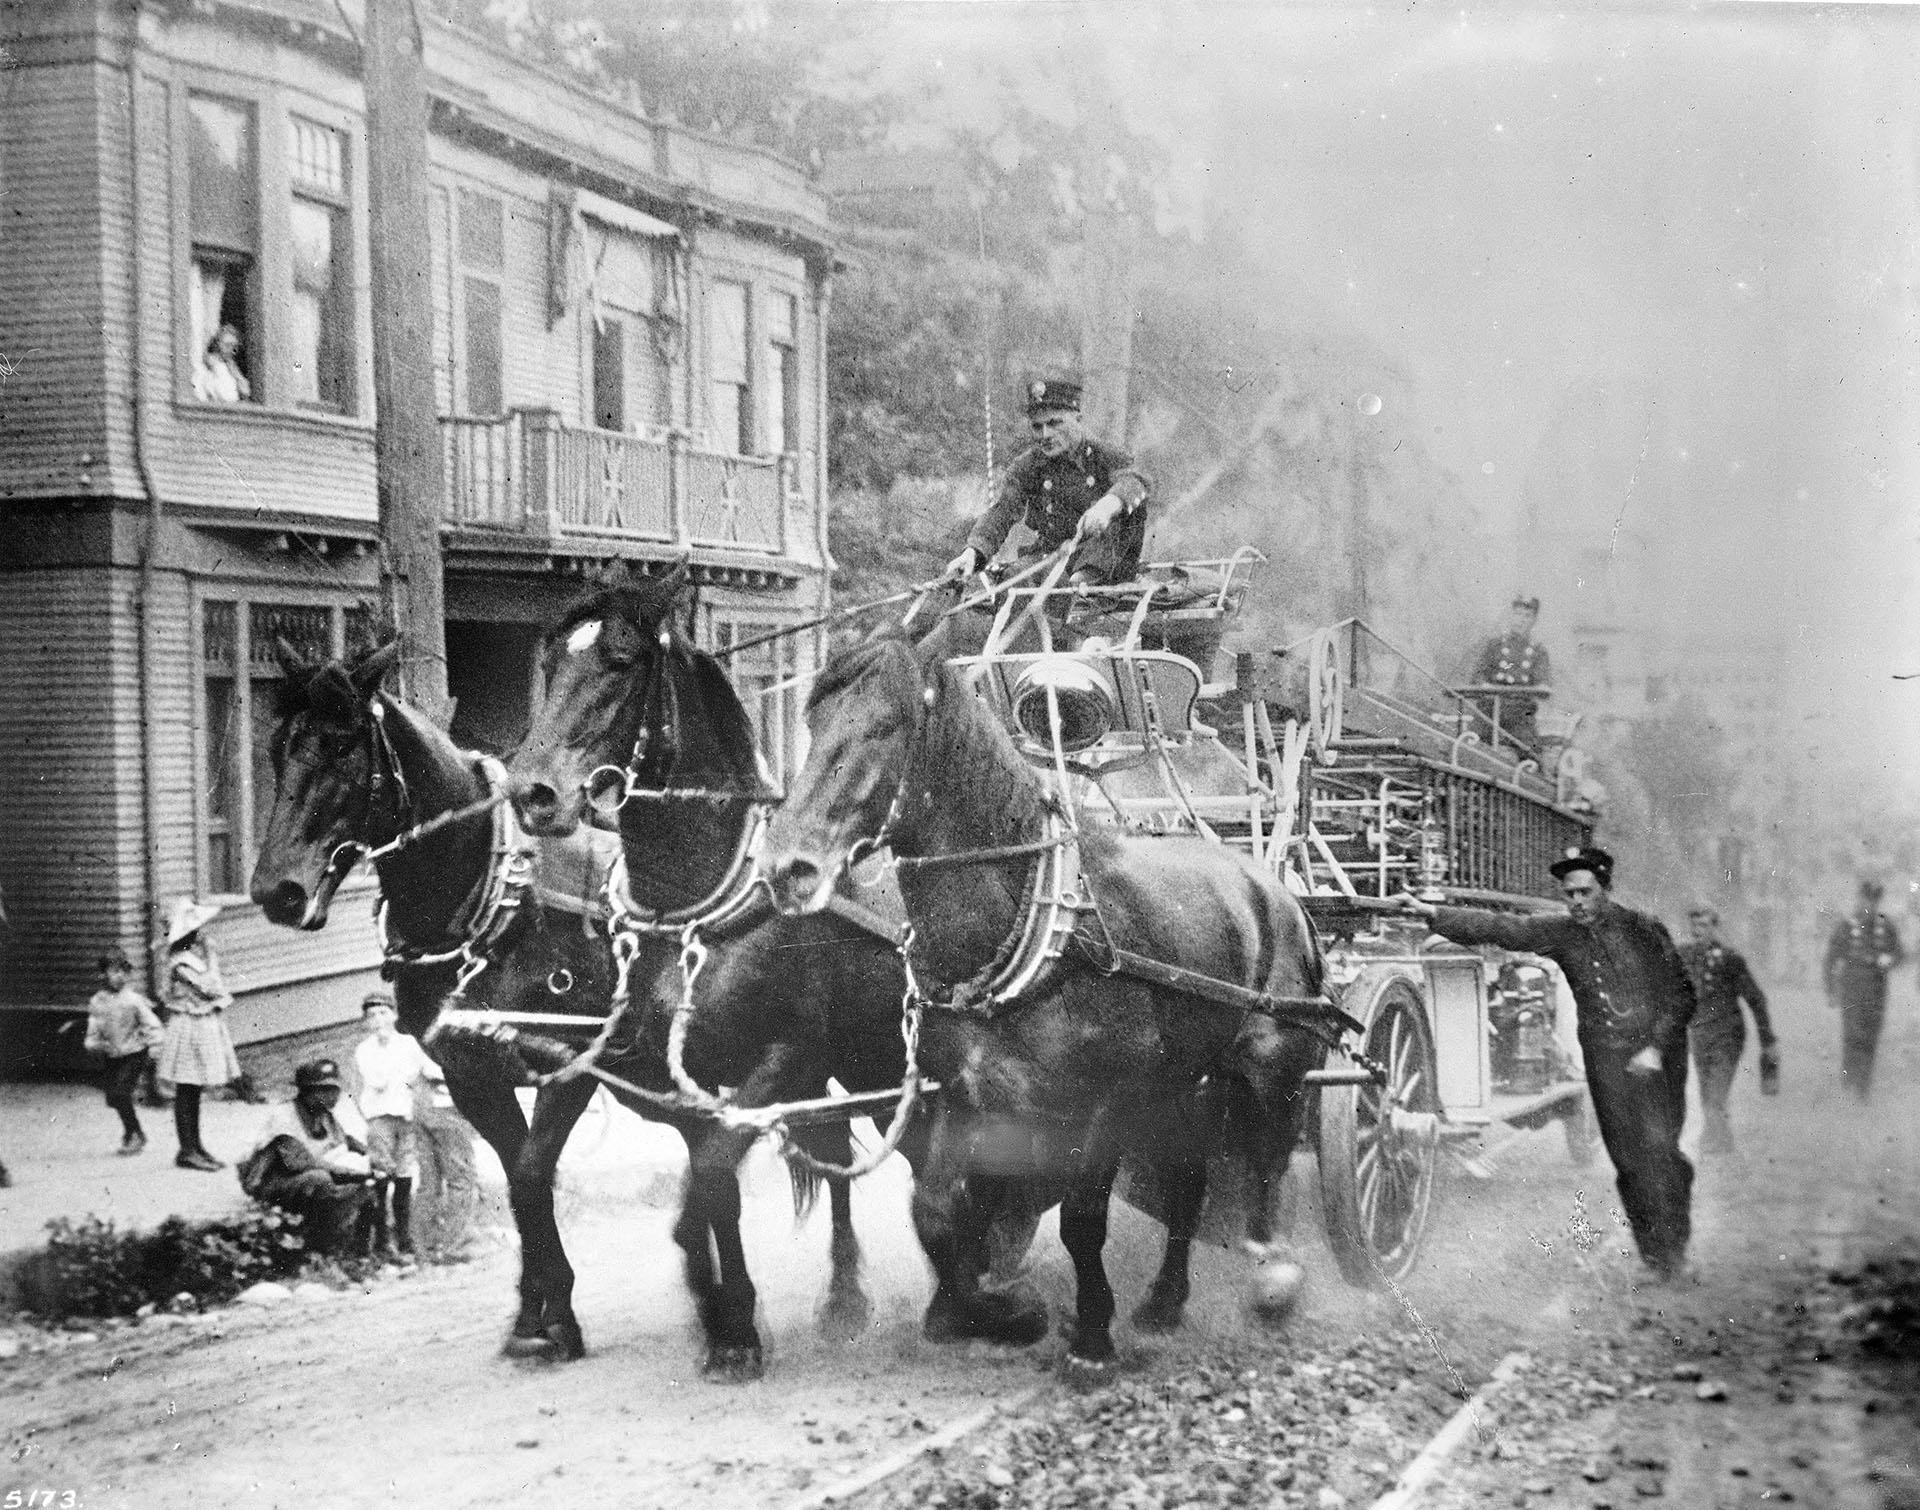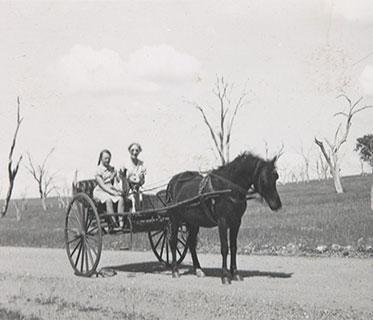The first image is the image on the left, the second image is the image on the right. For the images displayed, is the sentence "In one image, two people are sitting in a carriage with only two large wheels, which is pulled by one horse." factually correct? Answer yes or no. Yes. 